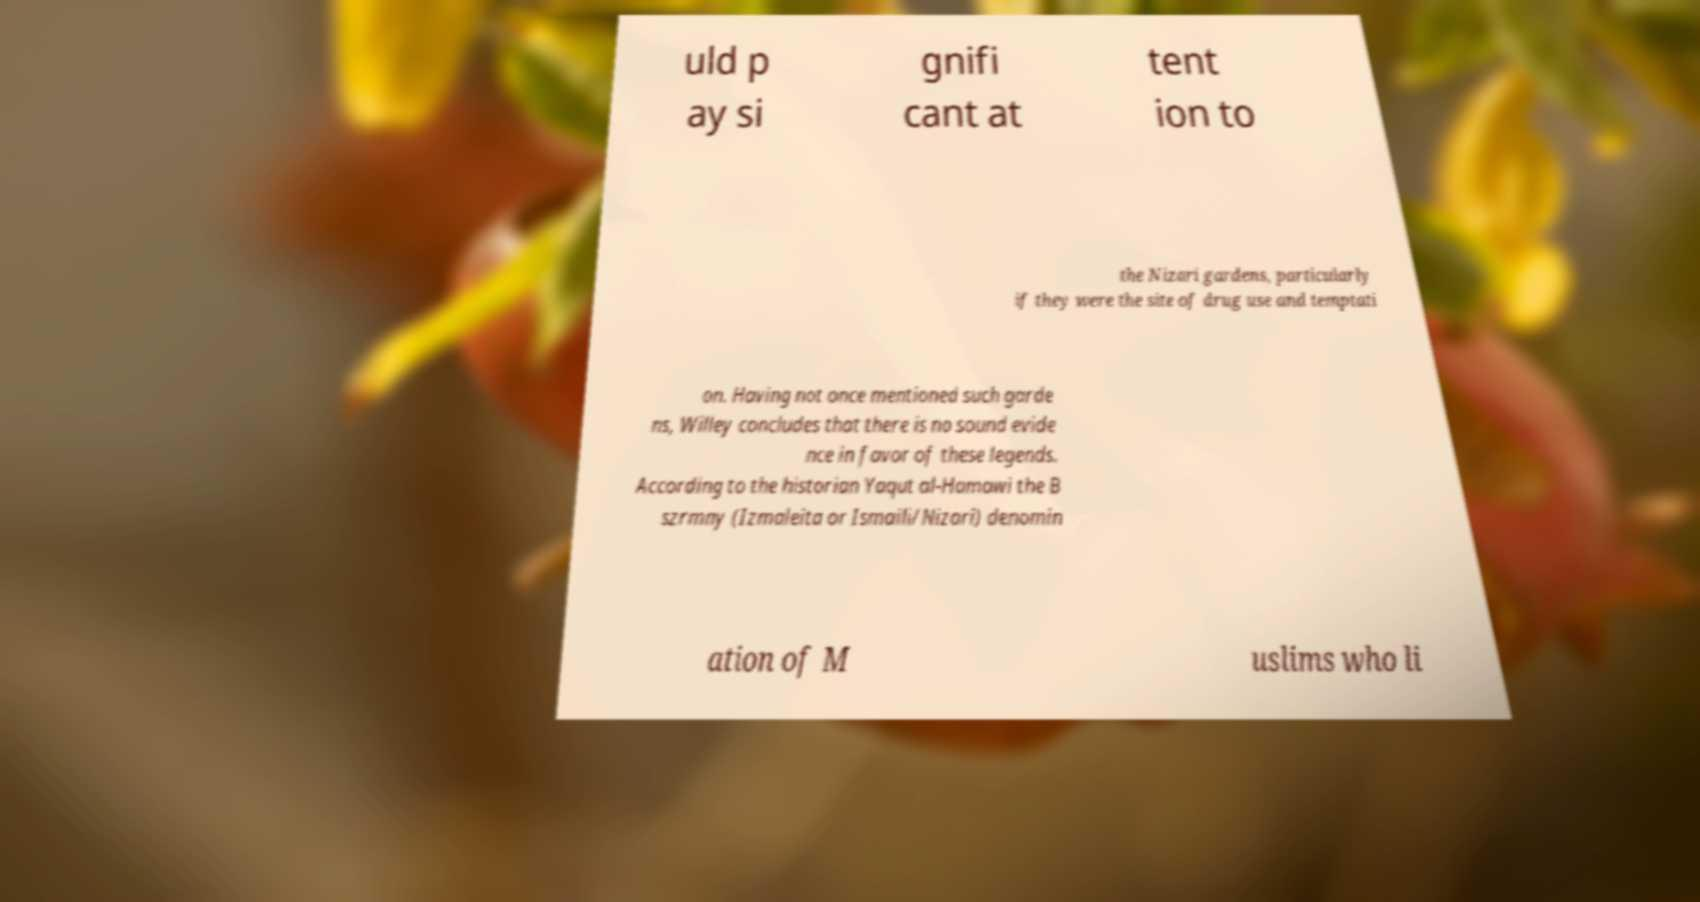Can you read and provide the text displayed in the image?This photo seems to have some interesting text. Can you extract and type it out for me? uld p ay si gnifi cant at tent ion to the Nizari gardens, particularly if they were the site of drug use and temptati on. Having not once mentioned such garde ns, Willey concludes that there is no sound evide nce in favor of these legends. According to the historian Yaqut al-Hamawi the B szrmny (Izmaleita or Ismaili/Nizari) denomin ation of M uslims who li 